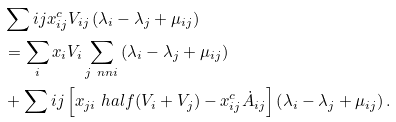Convert formula to latex. <formula><loc_0><loc_0><loc_500><loc_500>& \sum i j x _ { i j } ^ { c } V _ { i j } \left ( \lambda _ { i } - \lambda _ { j } + \mu _ { i j } \right ) \\ & = \sum _ { i } x _ { i } V _ { i } \sum _ { j \ n n i } \left ( \lambda _ { i } - \lambda _ { j } + \mu _ { i j } \right ) \\ & + \sum i j \left [ x _ { j i } \ h a l f ( V _ { i } + V _ { j } ) - x _ { i j } ^ { c } \dot { A } _ { i j } \right ] \left ( \lambda _ { i } - \lambda _ { j } + \mu _ { i j } \right ) .</formula> 